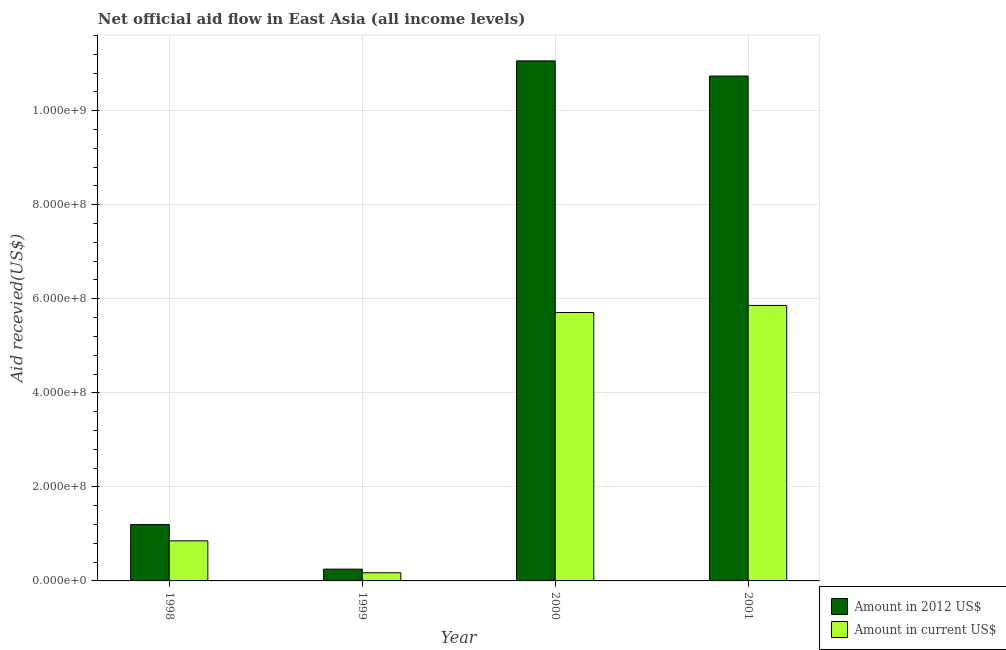How many groups of bars are there?
Make the answer very short. 4. Are the number of bars per tick equal to the number of legend labels?
Provide a succinct answer. Yes. How many bars are there on the 4th tick from the left?
Your response must be concise. 2. What is the label of the 1st group of bars from the left?
Keep it short and to the point. 1998. What is the amount of aid received(expressed in us$) in 1999?
Keep it short and to the point. 1.74e+07. Across all years, what is the maximum amount of aid received(expressed in us$)?
Keep it short and to the point. 5.86e+08. Across all years, what is the minimum amount of aid received(expressed in 2012 us$)?
Ensure brevity in your answer.  2.50e+07. What is the total amount of aid received(expressed in us$) in the graph?
Ensure brevity in your answer.  1.26e+09. What is the difference between the amount of aid received(expressed in 2012 us$) in 1999 and that in 2000?
Your response must be concise. -1.08e+09. What is the difference between the amount of aid received(expressed in us$) in 2000 and the amount of aid received(expressed in 2012 us$) in 1998?
Your answer should be compact. 4.86e+08. What is the average amount of aid received(expressed in us$) per year?
Keep it short and to the point. 3.15e+08. In the year 1999, what is the difference between the amount of aid received(expressed in us$) and amount of aid received(expressed in 2012 us$)?
Your answer should be compact. 0. What is the ratio of the amount of aid received(expressed in 2012 us$) in 1998 to that in 2000?
Keep it short and to the point. 0.11. Is the amount of aid received(expressed in us$) in 1998 less than that in 2001?
Give a very brief answer. Yes. Is the difference between the amount of aid received(expressed in 2012 us$) in 2000 and 2001 greater than the difference between the amount of aid received(expressed in us$) in 2000 and 2001?
Make the answer very short. No. What is the difference between the highest and the second highest amount of aid received(expressed in 2012 us$)?
Ensure brevity in your answer.  3.23e+07. What is the difference between the highest and the lowest amount of aid received(expressed in 2012 us$)?
Your response must be concise. 1.08e+09. Is the sum of the amount of aid received(expressed in 2012 us$) in 1998 and 2001 greater than the maximum amount of aid received(expressed in us$) across all years?
Make the answer very short. Yes. What does the 2nd bar from the left in 2000 represents?
Offer a very short reply. Amount in current US$. What does the 2nd bar from the right in 2001 represents?
Keep it short and to the point. Amount in 2012 US$. How many bars are there?
Offer a terse response. 8. Does the graph contain any zero values?
Your answer should be very brief. No. How many legend labels are there?
Your response must be concise. 2. What is the title of the graph?
Give a very brief answer. Net official aid flow in East Asia (all income levels). Does "Time to export" appear as one of the legend labels in the graph?
Your answer should be very brief. No. What is the label or title of the Y-axis?
Provide a short and direct response. Aid recevied(US$). What is the Aid recevied(US$) of Amount in 2012 US$ in 1998?
Your answer should be compact. 1.20e+08. What is the Aid recevied(US$) of Amount in current US$ in 1998?
Your answer should be compact. 8.52e+07. What is the Aid recevied(US$) of Amount in 2012 US$ in 1999?
Keep it short and to the point. 2.50e+07. What is the Aid recevied(US$) of Amount in current US$ in 1999?
Ensure brevity in your answer.  1.74e+07. What is the Aid recevied(US$) of Amount in 2012 US$ in 2000?
Provide a short and direct response. 1.11e+09. What is the Aid recevied(US$) of Amount in current US$ in 2000?
Make the answer very short. 5.71e+08. What is the Aid recevied(US$) of Amount in 2012 US$ in 2001?
Your answer should be compact. 1.07e+09. What is the Aid recevied(US$) in Amount in current US$ in 2001?
Give a very brief answer. 5.86e+08. Across all years, what is the maximum Aid recevied(US$) in Amount in 2012 US$?
Your answer should be very brief. 1.11e+09. Across all years, what is the maximum Aid recevied(US$) in Amount in current US$?
Make the answer very short. 5.86e+08. Across all years, what is the minimum Aid recevied(US$) of Amount in 2012 US$?
Your response must be concise. 2.50e+07. Across all years, what is the minimum Aid recevied(US$) in Amount in current US$?
Your answer should be very brief. 1.74e+07. What is the total Aid recevied(US$) in Amount in 2012 US$ in the graph?
Your answer should be compact. 2.32e+09. What is the total Aid recevied(US$) in Amount in current US$ in the graph?
Offer a very short reply. 1.26e+09. What is the difference between the Aid recevied(US$) in Amount in 2012 US$ in 1998 and that in 1999?
Give a very brief answer. 9.48e+07. What is the difference between the Aid recevied(US$) in Amount in current US$ in 1998 and that in 1999?
Your answer should be very brief. 6.79e+07. What is the difference between the Aid recevied(US$) of Amount in 2012 US$ in 1998 and that in 2000?
Give a very brief answer. -9.86e+08. What is the difference between the Aid recevied(US$) in Amount in current US$ in 1998 and that in 2000?
Your answer should be very brief. -4.86e+08. What is the difference between the Aid recevied(US$) of Amount in 2012 US$ in 1998 and that in 2001?
Offer a terse response. -9.54e+08. What is the difference between the Aid recevied(US$) in Amount in current US$ in 1998 and that in 2001?
Ensure brevity in your answer.  -5.01e+08. What is the difference between the Aid recevied(US$) in Amount in 2012 US$ in 1999 and that in 2000?
Provide a succinct answer. -1.08e+09. What is the difference between the Aid recevied(US$) in Amount in current US$ in 1999 and that in 2000?
Your answer should be very brief. -5.53e+08. What is the difference between the Aid recevied(US$) of Amount in 2012 US$ in 1999 and that in 2001?
Offer a terse response. -1.05e+09. What is the difference between the Aid recevied(US$) in Amount in current US$ in 1999 and that in 2001?
Keep it short and to the point. -5.68e+08. What is the difference between the Aid recevied(US$) of Amount in 2012 US$ in 2000 and that in 2001?
Offer a terse response. 3.23e+07. What is the difference between the Aid recevied(US$) of Amount in current US$ in 2000 and that in 2001?
Provide a succinct answer. -1.50e+07. What is the difference between the Aid recevied(US$) of Amount in 2012 US$ in 1998 and the Aid recevied(US$) of Amount in current US$ in 1999?
Your response must be concise. 1.02e+08. What is the difference between the Aid recevied(US$) in Amount in 2012 US$ in 1998 and the Aid recevied(US$) in Amount in current US$ in 2000?
Offer a terse response. -4.51e+08. What is the difference between the Aid recevied(US$) in Amount in 2012 US$ in 1998 and the Aid recevied(US$) in Amount in current US$ in 2001?
Your answer should be very brief. -4.66e+08. What is the difference between the Aid recevied(US$) of Amount in 2012 US$ in 1999 and the Aid recevied(US$) of Amount in current US$ in 2000?
Ensure brevity in your answer.  -5.46e+08. What is the difference between the Aid recevied(US$) of Amount in 2012 US$ in 1999 and the Aid recevied(US$) of Amount in current US$ in 2001?
Keep it short and to the point. -5.61e+08. What is the difference between the Aid recevied(US$) in Amount in 2012 US$ in 2000 and the Aid recevied(US$) in Amount in current US$ in 2001?
Offer a terse response. 5.20e+08. What is the average Aid recevied(US$) in Amount in 2012 US$ per year?
Provide a succinct answer. 5.81e+08. What is the average Aid recevied(US$) of Amount in current US$ per year?
Make the answer very short. 3.15e+08. In the year 1998, what is the difference between the Aid recevied(US$) in Amount in 2012 US$ and Aid recevied(US$) in Amount in current US$?
Make the answer very short. 3.45e+07. In the year 1999, what is the difference between the Aid recevied(US$) of Amount in 2012 US$ and Aid recevied(US$) of Amount in current US$?
Give a very brief answer. 7.68e+06. In the year 2000, what is the difference between the Aid recevied(US$) of Amount in 2012 US$ and Aid recevied(US$) of Amount in current US$?
Provide a succinct answer. 5.35e+08. In the year 2001, what is the difference between the Aid recevied(US$) of Amount in 2012 US$ and Aid recevied(US$) of Amount in current US$?
Make the answer very short. 4.88e+08. What is the ratio of the Aid recevied(US$) of Amount in 2012 US$ in 1998 to that in 1999?
Provide a short and direct response. 4.79. What is the ratio of the Aid recevied(US$) in Amount in current US$ in 1998 to that in 1999?
Provide a succinct answer. 4.91. What is the ratio of the Aid recevied(US$) of Amount in 2012 US$ in 1998 to that in 2000?
Your answer should be compact. 0.11. What is the ratio of the Aid recevied(US$) in Amount in current US$ in 1998 to that in 2000?
Provide a succinct answer. 0.15. What is the ratio of the Aid recevied(US$) of Amount in 2012 US$ in 1998 to that in 2001?
Ensure brevity in your answer.  0.11. What is the ratio of the Aid recevied(US$) of Amount in current US$ in 1998 to that in 2001?
Offer a terse response. 0.15. What is the ratio of the Aid recevied(US$) of Amount in 2012 US$ in 1999 to that in 2000?
Offer a very short reply. 0.02. What is the ratio of the Aid recevied(US$) in Amount in current US$ in 1999 to that in 2000?
Provide a short and direct response. 0.03. What is the ratio of the Aid recevied(US$) of Amount in 2012 US$ in 1999 to that in 2001?
Provide a succinct answer. 0.02. What is the ratio of the Aid recevied(US$) of Amount in current US$ in 1999 to that in 2001?
Your answer should be very brief. 0.03. What is the ratio of the Aid recevied(US$) in Amount in 2012 US$ in 2000 to that in 2001?
Your response must be concise. 1.03. What is the ratio of the Aid recevied(US$) of Amount in current US$ in 2000 to that in 2001?
Your response must be concise. 0.97. What is the difference between the highest and the second highest Aid recevied(US$) in Amount in 2012 US$?
Give a very brief answer. 3.23e+07. What is the difference between the highest and the second highest Aid recevied(US$) in Amount in current US$?
Your response must be concise. 1.50e+07. What is the difference between the highest and the lowest Aid recevied(US$) of Amount in 2012 US$?
Keep it short and to the point. 1.08e+09. What is the difference between the highest and the lowest Aid recevied(US$) of Amount in current US$?
Ensure brevity in your answer.  5.68e+08. 